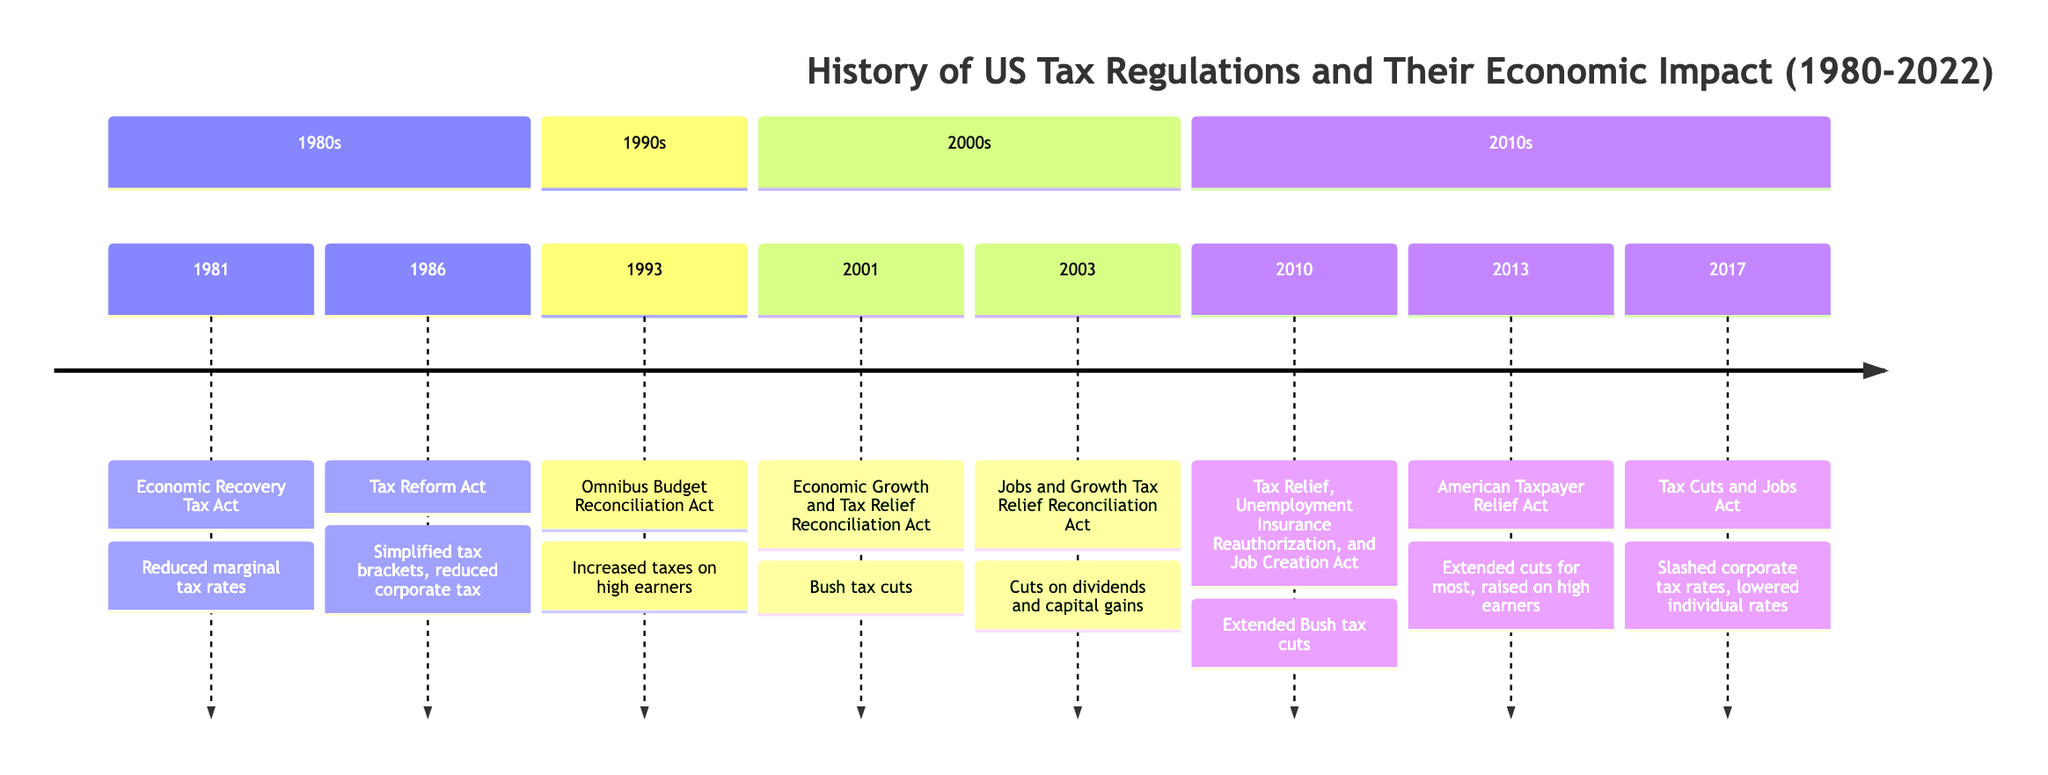What significant tax act was passed in 1981? The diagram indicates that the Economic Recovery Tax Act was signed into law in 1981. This is the major event listed for that year.
Answer: Economic Recovery Tax Act How many tax acts are listed for the 1990s? In the timeline, there is only one event recorded for the 1990s, which is the Omnibus Budget Reconciliation Act in 1993.
Answer: 1 What was a key feature of the Tax Cuts and Jobs Act of 2017? The timeline specifies that the Tax Cuts and Jobs Act slashed corporate tax rates from 35% to 21%, highlighting a significant change in tax policy.
Answer: Slashed corporate tax rates Which president signed the Tax Reform Act of 1986? The timeline shows that the Tax Reform Act was passed under President Ronald Reagan. This is the relevant event for that year.
Answer: Ronald Reagan What changes occurred under the Omnibus Budget Reconciliation Act of 1993? According to the timeline, this act raised taxes on higher income earners and businesses, which reflects significant shifts in tax policy during that time.
Answer: Increased taxes on high earners During which year was the American Taxpayer Relief Act signed? The diagram indicates that the American Taxpayer Relief Act was signed in the year 2013. This is the year specified in the timeline.
Answer: 2013 What was the intended goal of the Economic Growth and Tax Relief Reconciliation Act of 2001? The timeline reveals that this act aimed to stimulate the economy, which can be confirmed from the description associated with the event.
Answer: Stimulating the economy How did the Tax Relief Act of 2010 differ from previous tax policies? The timeline notes that it extended Bush-era tax cuts and temporarily reduced payroll taxes, indicating a continuation of previous tax policies rather than a significant overhaul.
Answer: Extended Bush tax cuts 